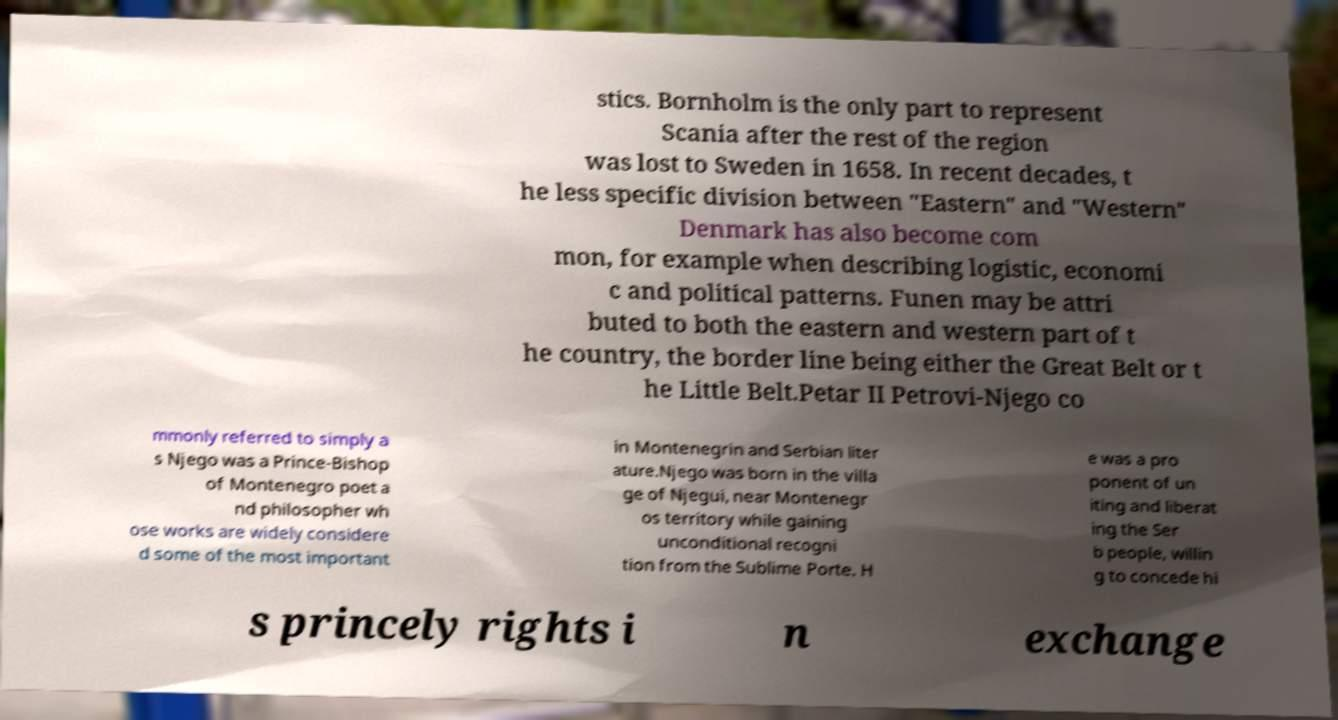There's text embedded in this image that I need extracted. Can you transcribe it verbatim? stics. Bornholm is the only part to represent Scania after the rest of the region was lost to Sweden in 1658. In recent decades, t he less specific division between "Eastern" and "Western" Denmark has also become com mon, for example when describing logistic, economi c and political patterns. Funen may be attri buted to both the eastern and western part of t he country, the border line being either the Great Belt or t he Little Belt.Petar II Petrovi-Njego co mmonly referred to simply a s Njego was a Prince-Bishop of Montenegro poet a nd philosopher wh ose works are widely considere d some of the most important in Montenegrin and Serbian liter ature.Njego was born in the villa ge of Njegui, near Montenegr os territory while gaining unconditional recogni tion from the Sublime Porte. H e was a pro ponent of un iting and liberat ing the Ser b people, willin g to concede hi s princely rights i n exchange 